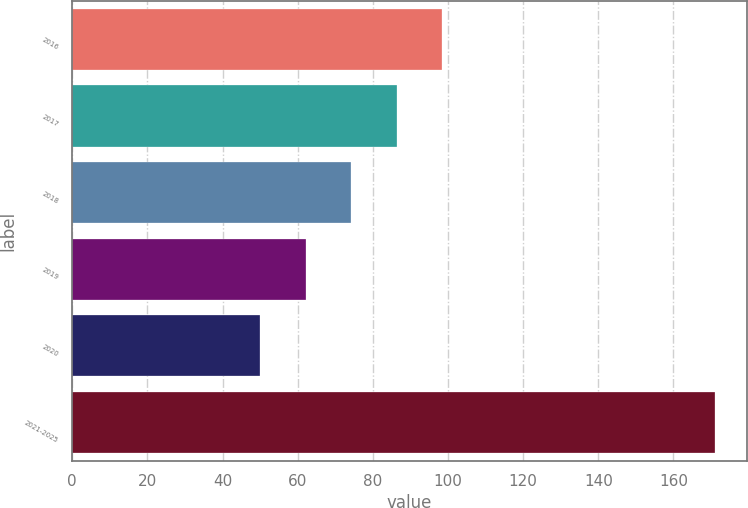Convert chart to OTSL. <chart><loc_0><loc_0><loc_500><loc_500><bar_chart><fcel>2016<fcel>2017<fcel>2018<fcel>2019<fcel>2020<fcel>2021-2025<nl><fcel>98.4<fcel>86.3<fcel>74.2<fcel>62.1<fcel>50<fcel>171<nl></chart> 